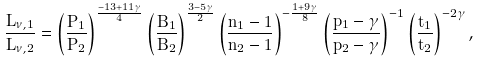<formula> <loc_0><loc_0><loc_500><loc_500>\frac { L _ { \nu , 1 } } { L _ { \nu , 2 } } = \left ( \frac { P _ { 1 } } { P _ { 2 } } \right ) ^ { \frac { - 1 3 + 1 1 \gamma } { 4 } } \left ( \frac { B _ { 1 } } { B _ { 2 } } \right ) ^ { \frac { 3 - 5 \gamma } { 2 } } \left ( \frac { n _ { 1 } - 1 } { n _ { 2 } - 1 } \right ) ^ { - \frac { 1 + 9 \gamma } { 8 } } \left ( \frac { p _ { 1 } - \gamma } { p _ { 2 } - \gamma } \right ) ^ { - 1 } \left ( \frac { t _ { 1 } } { t _ { 2 } } \right ) ^ { - 2 \gamma } ,</formula> 